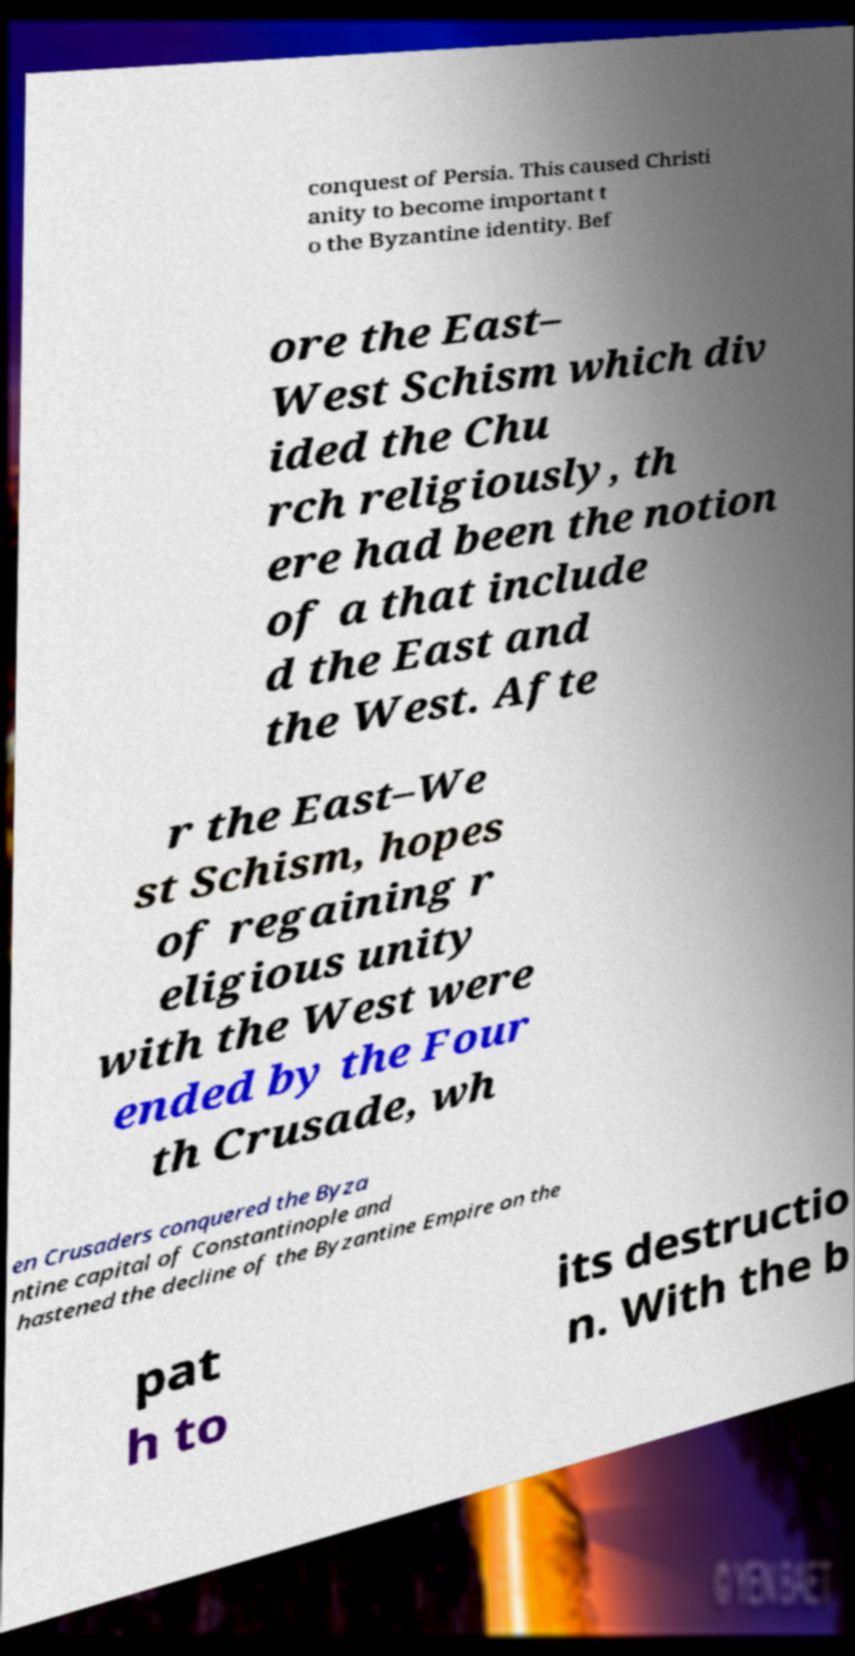There's text embedded in this image that I need extracted. Can you transcribe it verbatim? conquest of Persia. This caused Christi anity to become important t o the Byzantine identity. Bef ore the East– West Schism which div ided the Chu rch religiously, th ere had been the notion of a that include d the East and the West. Afte r the East–We st Schism, hopes of regaining r eligious unity with the West were ended by the Four th Crusade, wh en Crusaders conquered the Byza ntine capital of Constantinople and hastened the decline of the Byzantine Empire on the pat h to its destructio n. With the b 